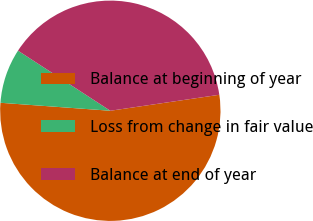Convert chart. <chart><loc_0><loc_0><loc_500><loc_500><pie_chart><fcel>Balance at beginning of year<fcel>Loss from change in fair value<fcel>Balance at end of year<nl><fcel>53.47%<fcel>8.03%<fcel>38.5%<nl></chart> 